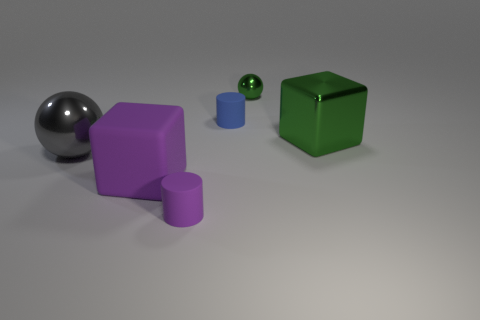Add 3 big purple cubes. How many objects exist? 9 Subtract 2 balls. How many balls are left? 0 Add 6 large metal balls. How many large metal balls exist? 7 Subtract all gray spheres. How many spheres are left? 1 Subtract 1 gray spheres. How many objects are left? 5 Subtract all cylinders. How many objects are left? 4 Subtract all green blocks. Subtract all purple balls. How many blocks are left? 1 Subtract all gray balls. How many brown cylinders are left? 0 Subtract all large gray shiny spheres. Subtract all large purple things. How many objects are left? 4 Add 5 tiny cylinders. How many tiny cylinders are left? 7 